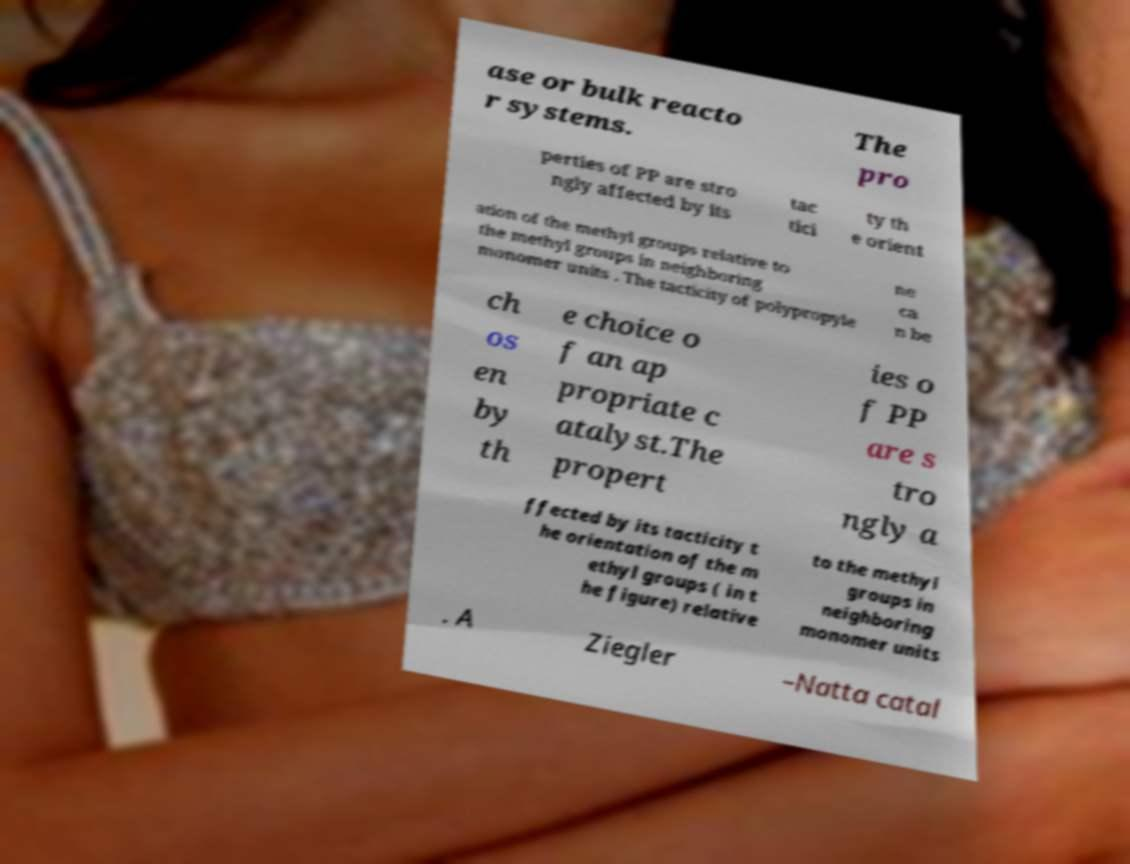For documentation purposes, I need the text within this image transcribed. Could you provide that? ase or bulk reacto r systems. The pro perties of PP are stro ngly affected by its tac tici ty th e orient ation of the methyl groups relative to the methyl groups in neighboring monomer units . The tacticity of polypropyle ne ca n be ch os en by th e choice o f an ap propriate c atalyst.The propert ies o f PP are s tro ngly a ffected by its tacticity t he orientation of the m ethyl groups ( in t he figure) relative to the methyl groups in neighboring monomer units . A Ziegler –Natta catal 